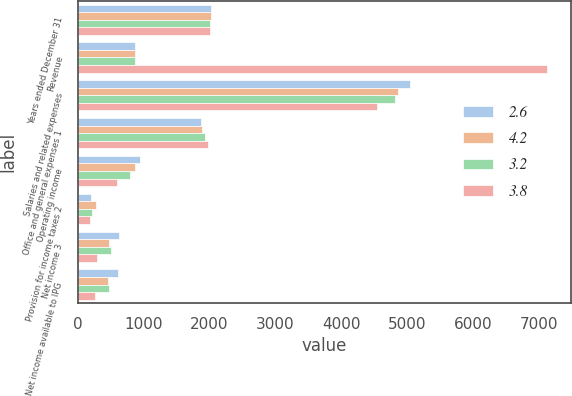Convert chart to OTSL. <chart><loc_0><loc_0><loc_500><loc_500><stacked_bar_chart><ecel><fcel>Years ended December 31<fcel>Revenue<fcel>Salaries and related expenses<fcel>Office and general expenses 1<fcel>Operating income<fcel>Provision for income taxes 2<fcel>Net income 3<fcel>Net income available to IPG<nl><fcel>2.6<fcel>2016<fcel>871.9<fcel>5038.1<fcel>1870.5<fcel>938<fcel>198<fcel>632.5<fcel>608.5<nl><fcel>4.2<fcel>2015<fcel>871.9<fcel>4857.7<fcel>1884.2<fcel>871.9<fcel>282.8<fcel>480.5<fcel>454.6<nl><fcel>3.2<fcel>2014<fcel>871.9<fcel>4820.4<fcel>1928.3<fcel>788.4<fcel>216.5<fcel>505.4<fcel>477.1<nl><fcel>3.8<fcel>2013<fcel>7122.3<fcel>4545.5<fcel>1978.5<fcel>598.3<fcel>181.2<fcel>288.9<fcel>259.2<nl></chart> 